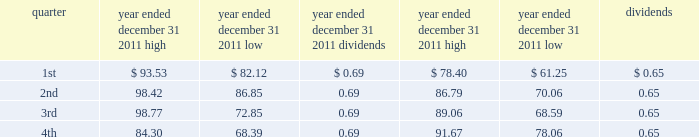Part ii item 5 .
Market for registrant 2019s common equity , related stockholder matters and issuer purchases of equity securities vornado 2019s common shares are traded on the new york stock exchange under the symbol 201cvno . 201d quarterly high and low sales prices of the common shares and dividends paid per share for the years ended december 31 , 2011 and 2010 were as follows : year ended year ended december 31 , 2011 december 31 , 2010 .
As of february 1 , 2012 , there were 1230 holders of record of our common shares .
Recent sales of unregistered securities during the fourth quarter of 2011 , we issued 20891 common shares upon the redemption of class a units of the operating partnership held by persons who received units , in private placements in earlier periods , in exchange for their interests in limited partnerships that owned real estate .
The common shares were issued without registration under the securities act of 1933 in reliance on section 4 ( 2 ) of that act .
Information relating to compensation plans under which our equity securities are authorized for issuance is set forth under part iii , item 12 of this annual report on form 10-k and such information is incorporated by reference herein .
Recent purchases of equity securities in december 2011 , we received 410783 vornado common shares at an average price of $ 76.36 per share as payment for the exercise of certain employee options. .
Was the quarterly high sales prices of the common shares and dividends paid per share for the first quarter of the year ended december 31 , 2011 higher than the fourth quarter of that period? 
Computations: (93.53 > 84.30)
Answer: yes. 